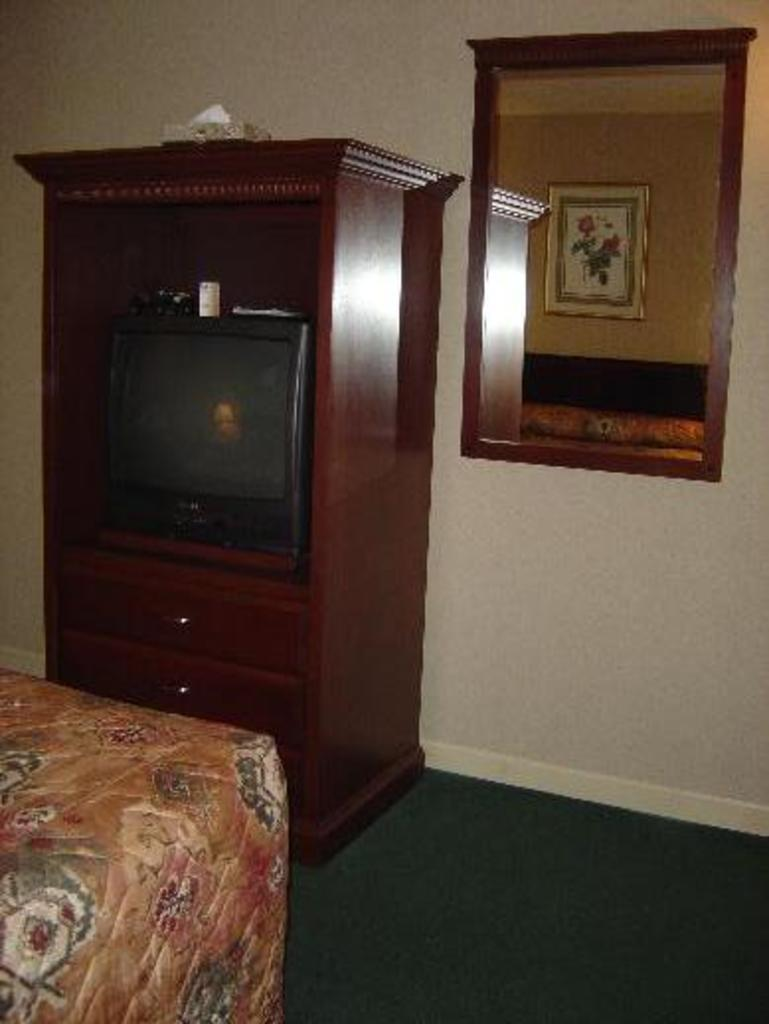What piece of furniture is located in the bottom left of the image? There is a bed in the bottom left of the image. What is in front of the bed? There is a desk with a television in front of the bed. What object is towards the right of the image? There is a mirror towards the right of the image. What does the mirror reflect in the image? The mirror reflects the frame. What type of quiver is hanging on the wall in the image? There is no quiver present in the image. How does the pot increase the aesthetic appeal of the room in the image? There is no pot mentioned in the image, so it cannot be determined how it would affect the aesthetic appeal of the room. 